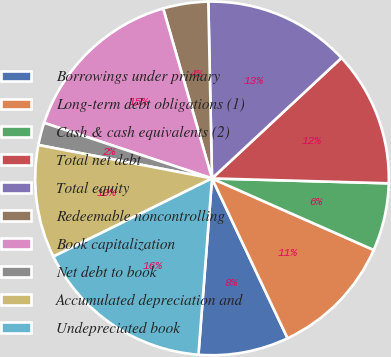Convert chart. <chart><loc_0><loc_0><loc_500><loc_500><pie_chart><fcel>Borrowings under primary<fcel>Long-term debt obligations (1)<fcel>Cash & cash equivalents (2)<fcel>Total net debt<fcel>Total equity<fcel>Redeemable noncontrolling<fcel>Book capitalization<fcel>Net debt to book<fcel>Accumulated depreciation and<fcel>Undepreciated book<nl><fcel>8.25%<fcel>11.34%<fcel>6.19%<fcel>12.37%<fcel>13.4%<fcel>4.12%<fcel>15.46%<fcel>2.06%<fcel>10.31%<fcel>16.49%<nl></chart> 